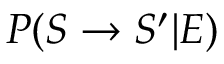Convert formula to latex. <formula><loc_0><loc_0><loc_500><loc_500>P ( S \rightarrow S ^ { \prime } | E )</formula> 